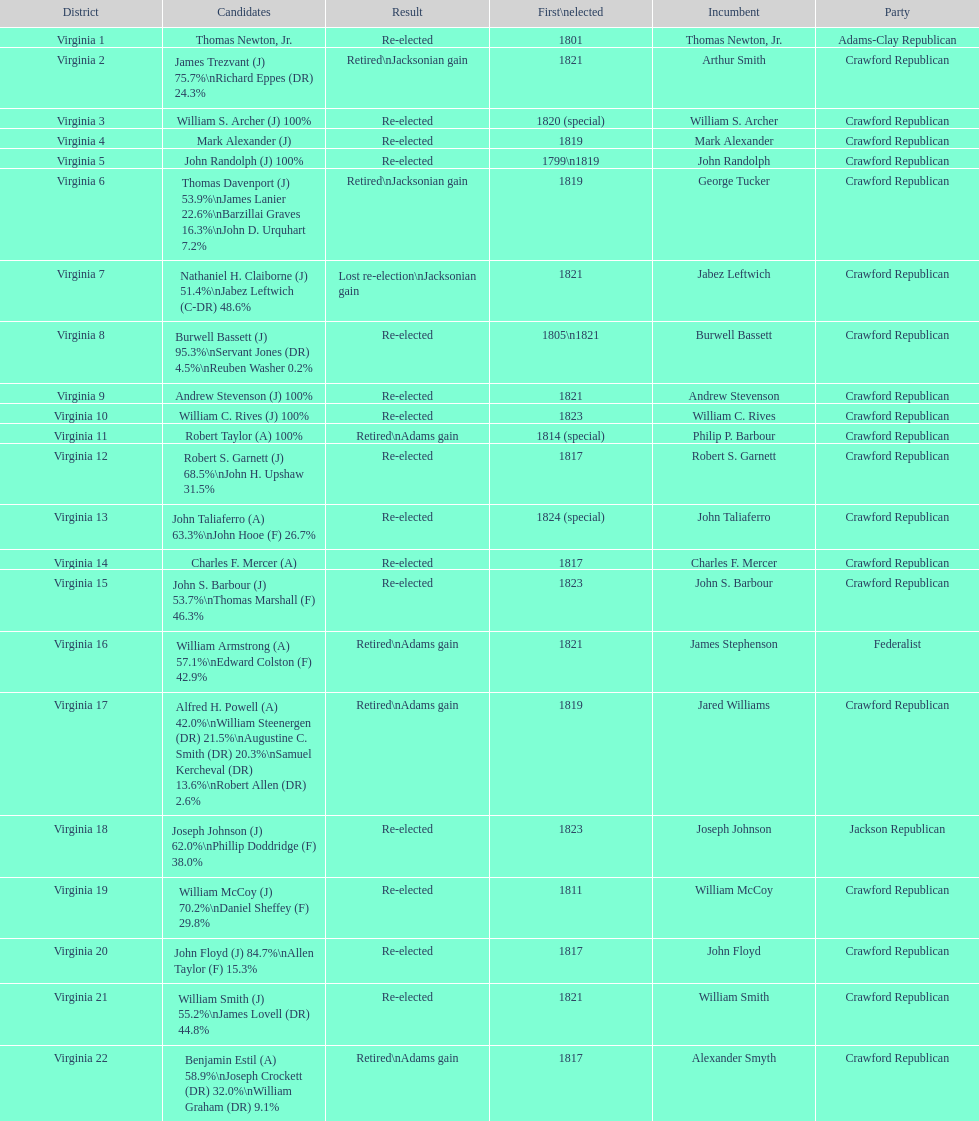Give me the full table as a dictionary. {'header': ['District', 'Candidates', 'Result', 'First\\nelected', 'Incumbent', 'Party'], 'rows': [['Virginia 1', 'Thomas Newton, Jr.', 'Re-elected', '1801', 'Thomas Newton, Jr.', 'Adams-Clay Republican'], ['Virginia 2', 'James Trezvant (J) 75.7%\\nRichard Eppes (DR) 24.3%', 'Retired\\nJacksonian gain', '1821', 'Arthur Smith', 'Crawford Republican'], ['Virginia 3', 'William S. Archer (J) 100%', 'Re-elected', '1820 (special)', 'William S. Archer', 'Crawford Republican'], ['Virginia 4', 'Mark Alexander (J)', 'Re-elected', '1819', 'Mark Alexander', 'Crawford Republican'], ['Virginia 5', 'John Randolph (J) 100%', 'Re-elected', '1799\\n1819', 'John Randolph', 'Crawford Republican'], ['Virginia 6', 'Thomas Davenport (J) 53.9%\\nJames Lanier 22.6%\\nBarzillai Graves 16.3%\\nJohn D. Urquhart 7.2%', 'Retired\\nJacksonian gain', '1819', 'George Tucker', 'Crawford Republican'], ['Virginia 7', 'Nathaniel H. Claiborne (J) 51.4%\\nJabez Leftwich (C-DR) 48.6%', 'Lost re-election\\nJacksonian gain', '1821', 'Jabez Leftwich', 'Crawford Republican'], ['Virginia 8', 'Burwell Bassett (J) 95.3%\\nServant Jones (DR) 4.5%\\nReuben Washer 0.2%', 'Re-elected', '1805\\n1821', 'Burwell Bassett', 'Crawford Republican'], ['Virginia 9', 'Andrew Stevenson (J) 100%', 'Re-elected', '1821', 'Andrew Stevenson', 'Crawford Republican'], ['Virginia 10', 'William C. Rives (J) 100%', 'Re-elected', '1823', 'William C. Rives', 'Crawford Republican'], ['Virginia 11', 'Robert Taylor (A) 100%', 'Retired\\nAdams gain', '1814 (special)', 'Philip P. Barbour', 'Crawford Republican'], ['Virginia 12', 'Robert S. Garnett (J) 68.5%\\nJohn H. Upshaw 31.5%', 'Re-elected', '1817', 'Robert S. Garnett', 'Crawford Republican'], ['Virginia 13', 'John Taliaferro (A) 63.3%\\nJohn Hooe (F) 26.7%', 'Re-elected', '1824 (special)', 'John Taliaferro', 'Crawford Republican'], ['Virginia 14', 'Charles F. Mercer (A)', 'Re-elected', '1817', 'Charles F. Mercer', 'Crawford Republican'], ['Virginia 15', 'John S. Barbour (J) 53.7%\\nThomas Marshall (F) 46.3%', 'Re-elected', '1823', 'John S. Barbour', 'Crawford Republican'], ['Virginia 16', 'William Armstrong (A) 57.1%\\nEdward Colston (F) 42.9%', 'Retired\\nAdams gain', '1821', 'James Stephenson', 'Federalist'], ['Virginia 17', 'Alfred H. Powell (A) 42.0%\\nWilliam Steenergen (DR) 21.5%\\nAugustine C. Smith (DR) 20.3%\\nSamuel Kercheval (DR) 13.6%\\nRobert Allen (DR) 2.6%', 'Retired\\nAdams gain', '1819', 'Jared Williams', 'Crawford Republican'], ['Virginia 18', 'Joseph Johnson (J) 62.0%\\nPhillip Doddridge (F) 38.0%', 'Re-elected', '1823', 'Joseph Johnson', 'Jackson Republican'], ['Virginia 19', 'William McCoy (J) 70.2%\\nDaniel Sheffey (F) 29.8%', 'Re-elected', '1811', 'William McCoy', 'Crawford Republican'], ['Virginia 20', 'John Floyd (J) 84.7%\\nAllen Taylor (F) 15.3%', 'Re-elected', '1817', 'John Floyd', 'Crawford Republican'], ['Virginia 21', 'William Smith (J) 55.2%\\nJames Lovell (DR) 44.8%', 'Re-elected', '1821', 'William Smith', 'Crawford Republican'], ['Virginia 22', 'Benjamin Estil (A) 58.9%\\nJoseph Crockett (DR) 32.0%\\nWilliam Graham (DR) 9.1%', 'Retired\\nAdams gain', '1817', 'Alexander Smyth', 'Crawford Republican']]} Name the only candidate that was first elected in 1811. William McCoy. 